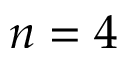<formula> <loc_0><loc_0><loc_500><loc_500>n = 4</formula> 